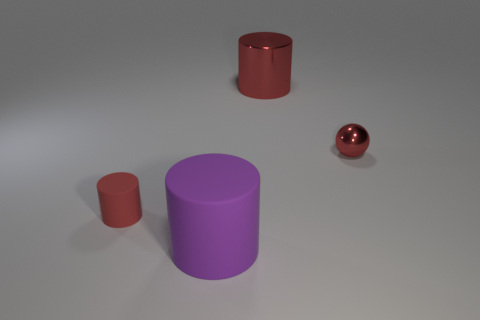Subtract all red cylinders. How many were subtracted if there are1red cylinders left? 1 Subtract all red cylinders. How many cylinders are left? 1 Subtract 1 cylinders. How many cylinders are left? 2 Add 2 red matte cylinders. How many red matte cylinders exist? 3 Add 1 small balls. How many objects exist? 5 Subtract all purple cylinders. How many cylinders are left? 2 Subtract 0 cyan cylinders. How many objects are left? 4 Subtract all balls. How many objects are left? 3 Subtract all brown cylinders. Subtract all purple spheres. How many cylinders are left? 3 Subtract all gray cylinders. How many purple balls are left? 0 